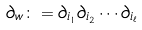<formula> <loc_0><loc_0><loc_500><loc_500>\partial _ { w } \colon = \partial _ { i _ { 1 } } \partial _ { i _ { 2 } } \cdots \partial _ { i _ { \ell } }</formula> 